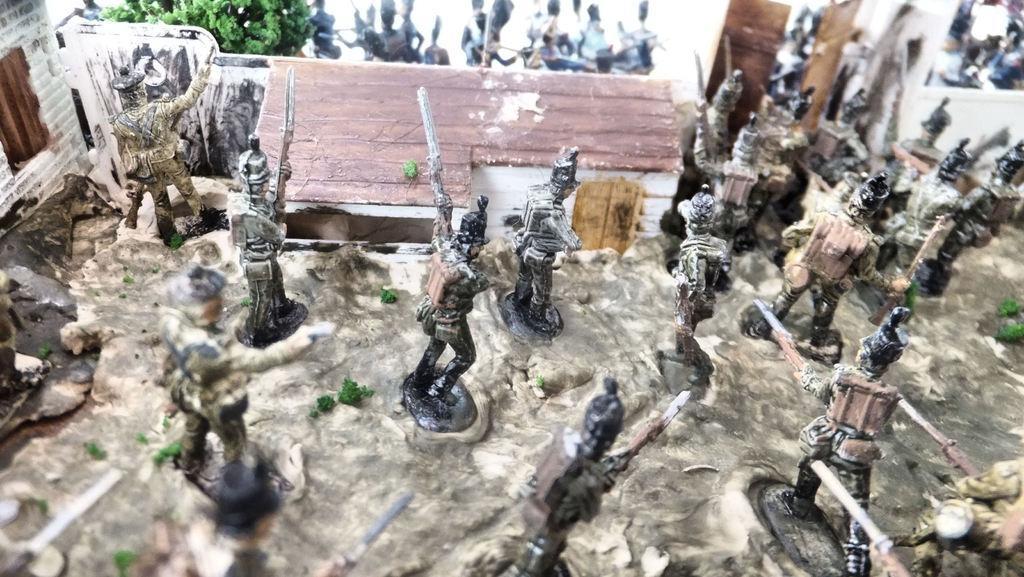Can you describe this image briefly? In the picture I can see toys in the shape of people, house and some other things. 